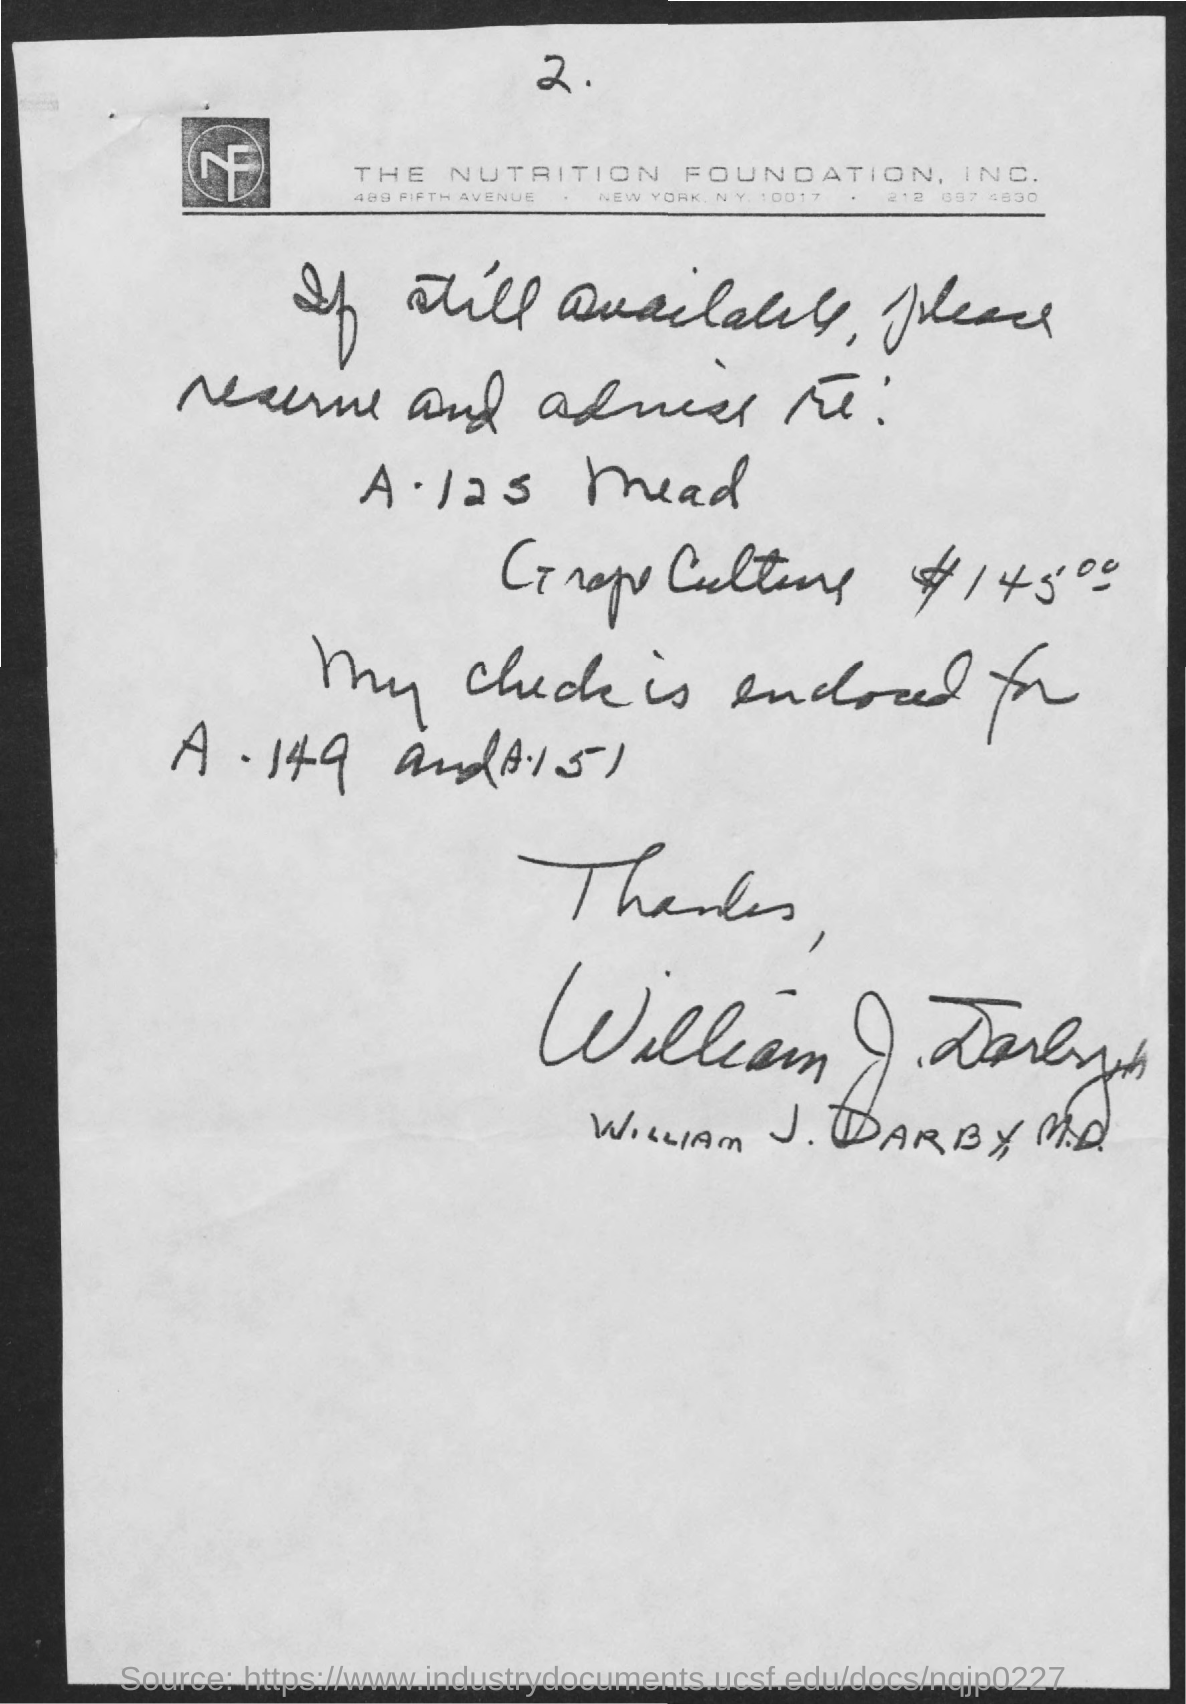Which is the foundation mentioned in the document?
Provide a short and direct response. The nutrition foundation, inc. Who is the sender of this letter?
Keep it short and to the point. William J. Darby. 